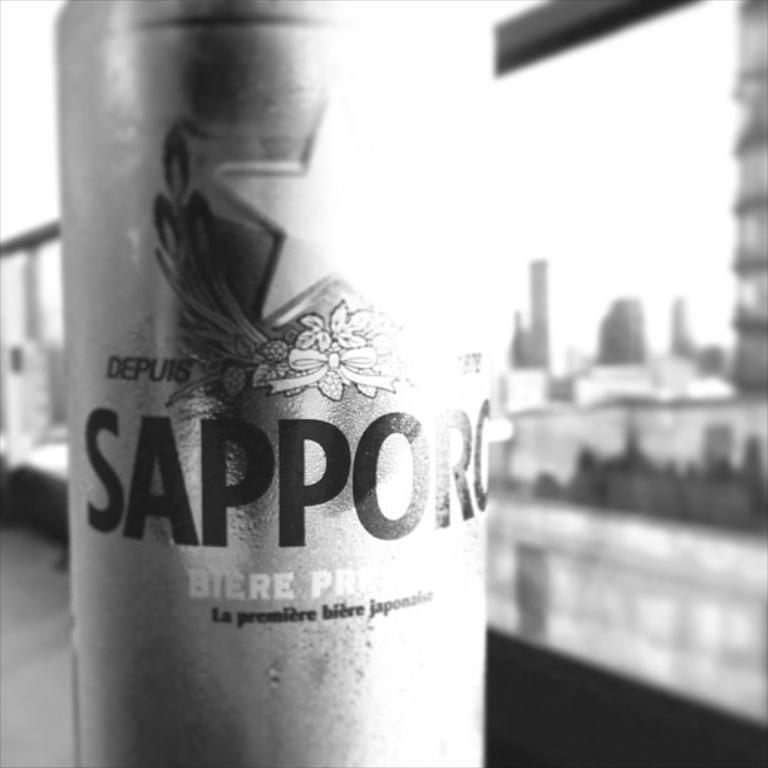<image>
Relay a brief, clear account of the picture shown. A close up black and white image of a can of Sapporo beer. 